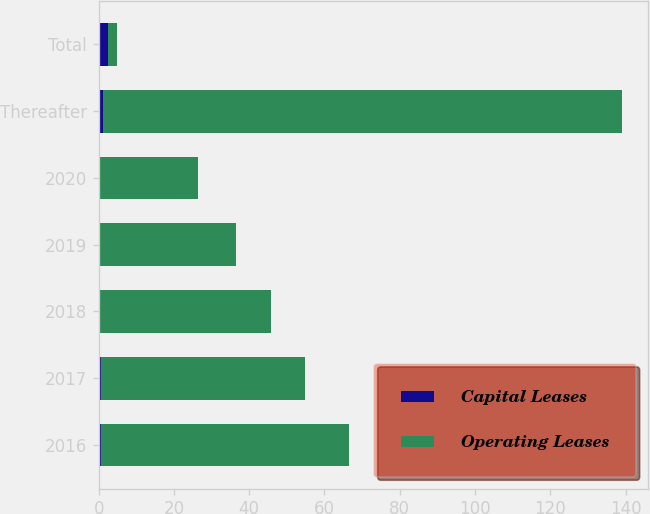<chart> <loc_0><loc_0><loc_500><loc_500><stacked_bar_chart><ecel><fcel>2016<fcel>2017<fcel>2018<fcel>2019<fcel>2020<fcel>Thereafter<fcel>Total<nl><fcel>Capital Leases<fcel>0.5<fcel>0.5<fcel>0.2<fcel>0.1<fcel>0.1<fcel>1.1<fcel>2.5<nl><fcel>Operating Leases<fcel>65.9<fcel>54.4<fcel>45.7<fcel>36.4<fcel>26.4<fcel>137.9<fcel>2.5<nl></chart> 